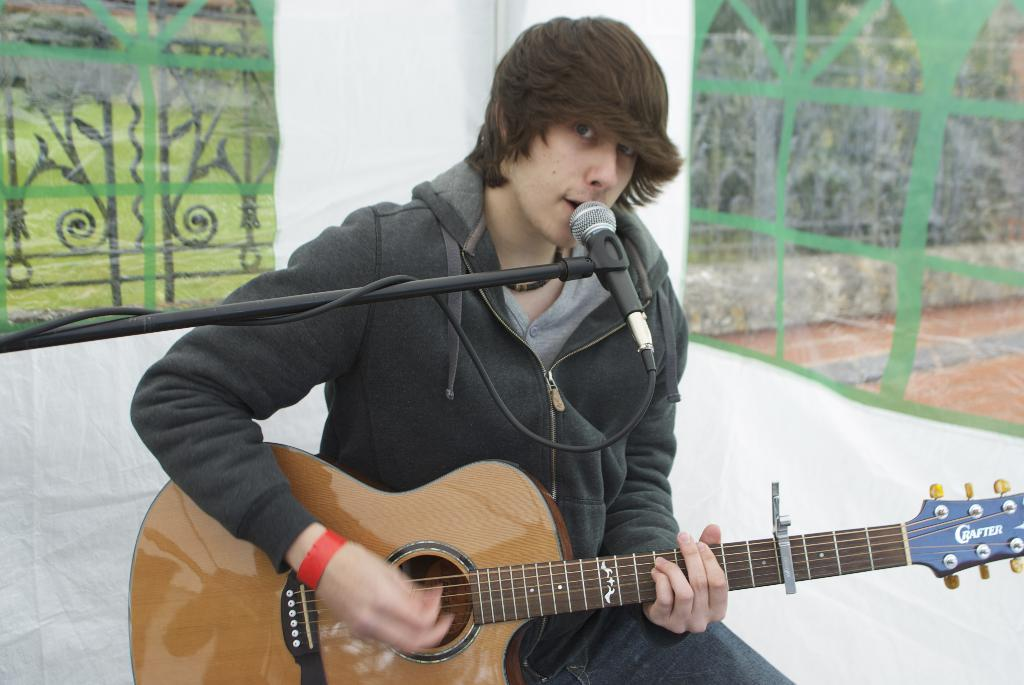What is the person in the image doing? The person is singing a song. What object is the person holding in the image? The person is holding a microphone. What is the person sitting on in the image? The person is sitting on a chair. What is the color of the background in the image? The background of the image is white. What type of destruction can be seen happening in the image? There is no destruction present in the image; it features a person singing with a microphone while sitting on a chair. What boundary is visible in the image? There is no boundary visible in the image; it has a white background with no distinct edges or lines. 